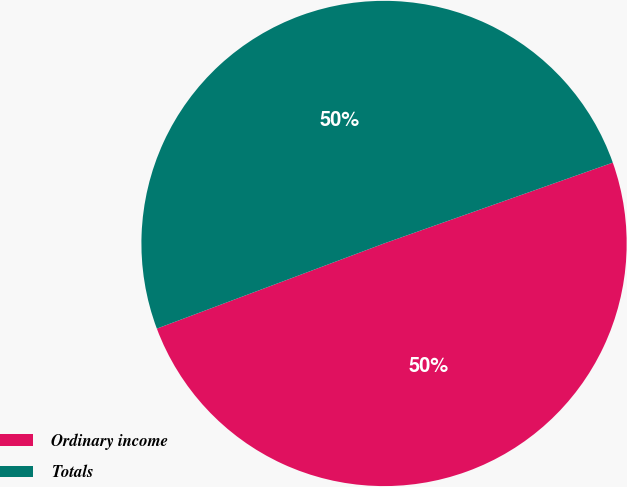Convert chart to OTSL. <chart><loc_0><loc_0><loc_500><loc_500><pie_chart><fcel>Ordinary income<fcel>Totals<nl><fcel>49.7%<fcel>50.3%<nl></chart> 